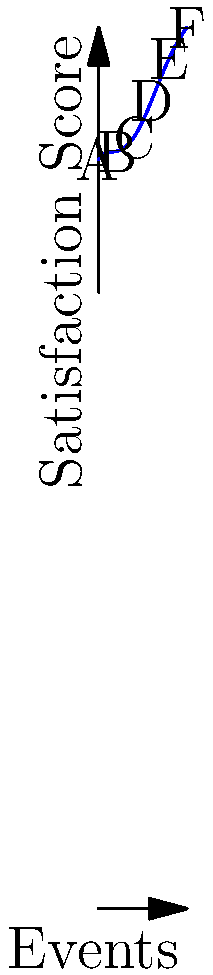You've organized six events (A through F) and collected guest satisfaction scores. The quintic polynomial function $f(x) = 0.001x^5 - 0.03x^4 + 0.3x^3 - x^2 + 1.5x + 85$ represents the trend of satisfaction scores across these events. Which event had the lowest guest satisfaction score, and what was the approximate score? To find the event with the lowest guest satisfaction score, we need to evaluate the function at each event point and compare the results:

1. Event A (x = 0): $f(0) = 85$
2. Event B (x = 2): $f(2) = 0.001(2^5) - 0.03(2^4) + 0.3(2^3) - 2^2 + 1.5(2) + 85 \approx 86.14$
3. Event C (x = 4): $f(4) \approx 84.61$
4. Event D (x = 6): $f(6) \approx 83.95$
5. Event E (x = 8): $f(8) \approx 89.25$
6. Event F (x = 10): $f(10) \approx 110.10$

Comparing these values, we can see that Event D (x = 6) has the lowest satisfaction score of approximately 83.95.
Answer: Event D, 83.95 